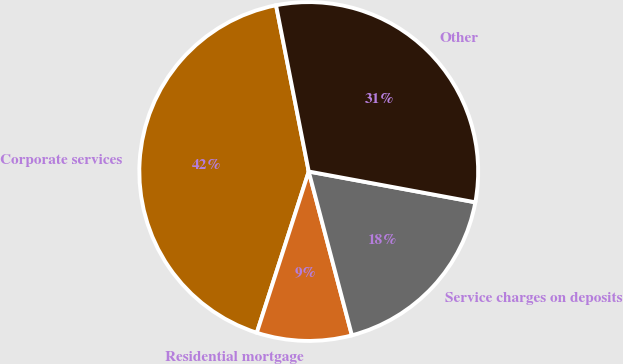Convert chart. <chart><loc_0><loc_0><loc_500><loc_500><pie_chart><fcel>Corporate services<fcel>Residential mortgage<fcel>Service charges on deposits<fcel>Other<nl><fcel>41.95%<fcel>9.06%<fcel>17.99%<fcel>31.0%<nl></chart> 